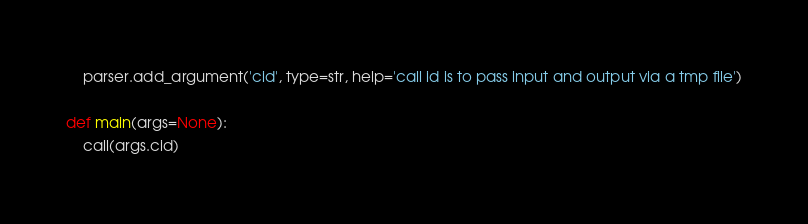Convert code to text. <code><loc_0><loc_0><loc_500><loc_500><_Python_>    parser.add_argument('cid', type=str, help='call id is to pass input and output via a tmp file')

def main(args=None):
    call(args.cid)
</code> 